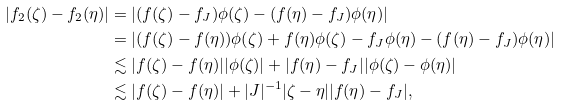Convert formula to latex. <formula><loc_0><loc_0><loc_500><loc_500>| f _ { 2 } ( \zeta ) - f _ { 2 } ( \eta ) | & = | ( f ( \zeta ) - f _ { J } ) \phi ( \zeta ) - ( f ( \eta ) - f _ { J } ) \phi ( \eta ) | \\ & = | ( f ( \zeta ) - f ( \eta ) ) \phi ( \zeta ) + f ( \eta ) \phi ( \zeta ) - f _ { J } \phi ( \eta ) - ( f ( \eta ) - f _ { J } ) \phi ( \eta ) | \\ & \lesssim | f ( \zeta ) - f ( \eta ) | | \phi ( \zeta ) | + | f ( \eta ) - f _ { J } | | \phi ( \zeta ) - \phi ( \eta ) | \\ & \lesssim | f ( \zeta ) - f ( \eta ) | + | J | ^ { - 1 } | \zeta - \eta | | f ( \eta ) - f _ { J } | ,</formula> 